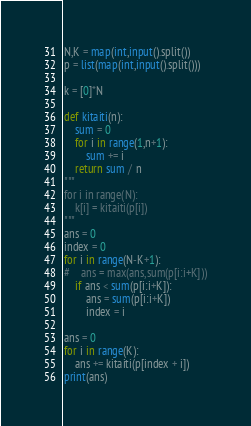<code> <loc_0><loc_0><loc_500><loc_500><_Python_>N,K = map(int,input().split())
p = list(map(int,input().split()))

k = [0]*N

def kitaiti(n):
    sum = 0
    for i in range(1,n+1):
        sum += i
    return sum / n
"""    
for i in range(N):
    k[i] = kitaiti(p[i])
"""
ans = 0
index = 0
for i in range(N-K+1):
#    ans = max(ans,sum(p[i:i+K]))
    if ans < sum(p[i:i+K]):
        ans = sum(p[i:i+K])
        index = i

ans = 0
for i in range(K):
    ans += kitaiti(p[index + i])
print(ans)
</code> 